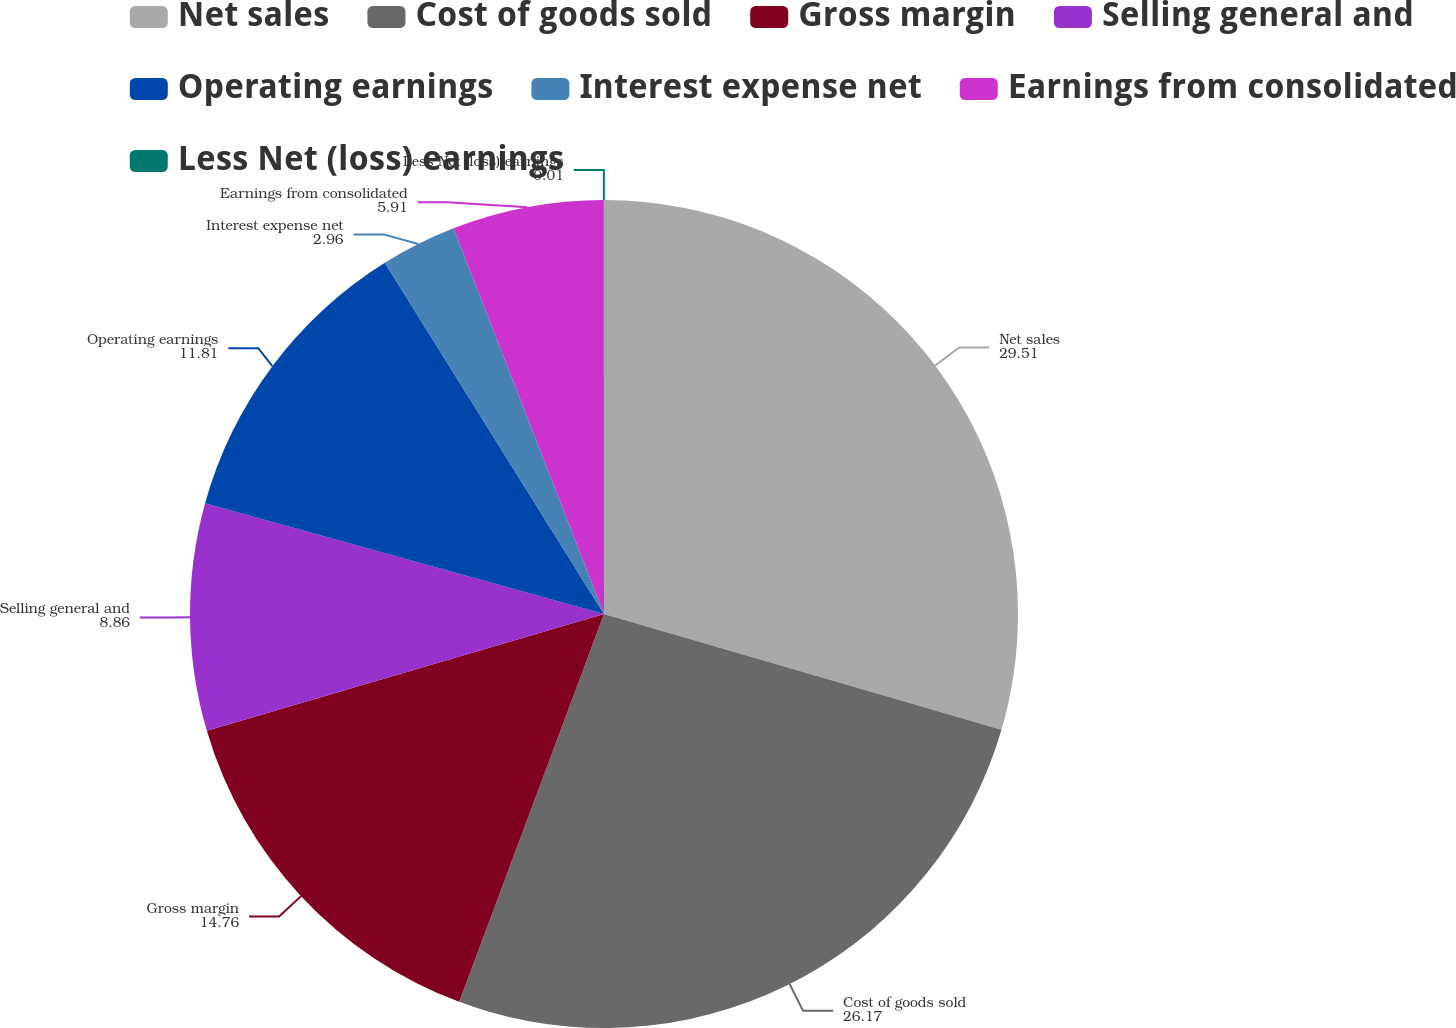Convert chart. <chart><loc_0><loc_0><loc_500><loc_500><pie_chart><fcel>Net sales<fcel>Cost of goods sold<fcel>Gross margin<fcel>Selling general and<fcel>Operating earnings<fcel>Interest expense net<fcel>Earnings from consolidated<fcel>Less Net (loss) earnings<nl><fcel>29.51%<fcel>26.17%<fcel>14.76%<fcel>8.86%<fcel>11.81%<fcel>2.96%<fcel>5.91%<fcel>0.01%<nl></chart> 